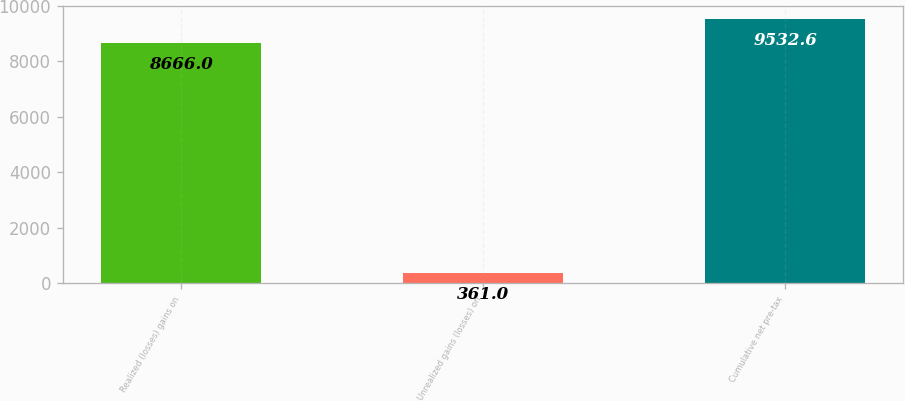Convert chart to OTSL. <chart><loc_0><loc_0><loc_500><loc_500><bar_chart><fcel>Realized (losses) gains on<fcel>Unrealized gains (losses) on<fcel>Cumulative net pre-tax<nl><fcel>8666<fcel>361<fcel>9532.6<nl></chart> 